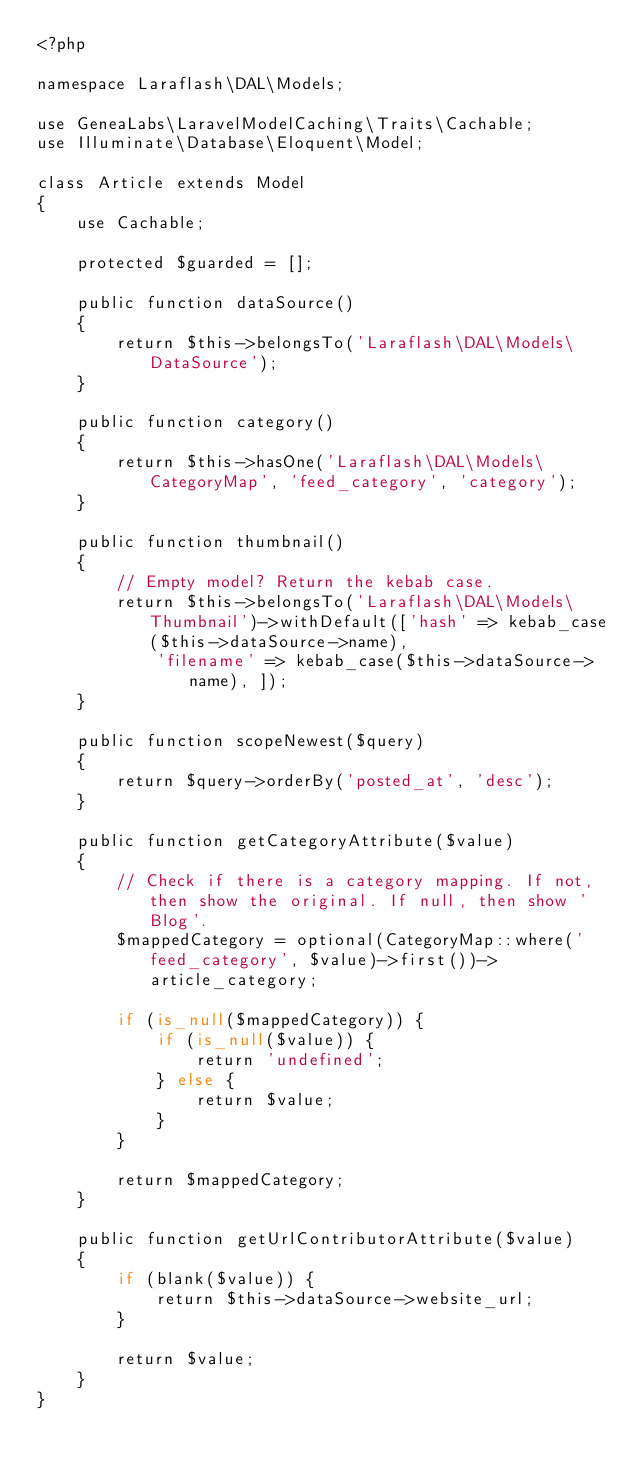Convert code to text. <code><loc_0><loc_0><loc_500><loc_500><_PHP_><?php

namespace Laraflash\DAL\Models;

use GeneaLabs\LaravelModelCaching\Traits\Cachable;
use Illuminate\Database\Eloquent\Model;

class Article extends Model
{
    use Cachable;

    protected $guarded = [];

    public function dataSource()
    {
        return $this->belongsTo('Laraflash\DAL\Models\DataSource');
    }

    public function category()
    {
        return $this->hasOne('Laraflash\DAL\Models\CategoryMap', 'feed_category', 'category');
    }

    public function thumbnail()
    {
        // Empty model? Return the kebab case.
        return $this->belongsTo('Laraflash\DAL\Models\Thumbnail')->withDefault(['hash' => kebab_case($this->dataSource->name),
            'filename' => kebab_case($this->dataSource->name), ]);
    }

    public function scopeNewest($query)
    {
        return $query->orderBy('posted_at', 'desc');
    }

    public function getCategoryAttribute($value)
    {
        // Check if there is a category mapping. If not, then show the original. If null, then show 'Blog'.
        $mappedCategory = optional(CategoryMap::where('feed_category', $value)->first())->article_category;

        if (is_null($mappedCategory)) {
            if (is_null($value)) {
                return 'undefined';
            } else {
                return $value;
            }
        }

        return $mappedCategory;
    }

    public function getUrlContributorAttribute($value)
    {
        if (blank($value)) {
            return $this->dataSource->website_url;
        }

        return $value;
    }
}
</code> 